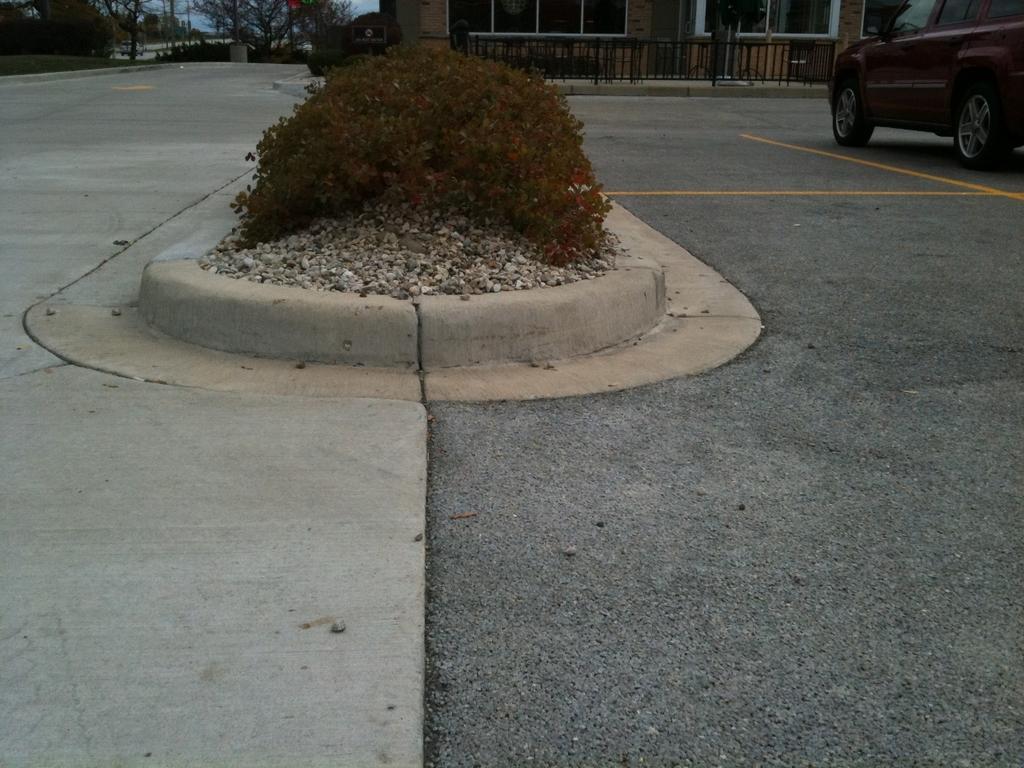In one or two sentences, can you explain what this image depicts? At the bottom of the image there is a road. On the right we can see a car. In the background there is a building and trees. We can see a shrub. 